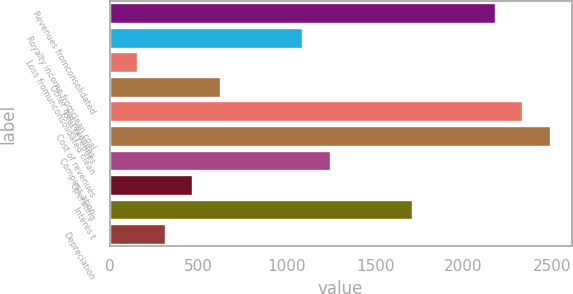Convert chart to OTSL. <chart><loc_0><loc_0><loc_500><loc_500><bar_chart><fcel>Revenues fromconsolidated<fcel>Royalty income fromclean coal<fcel>Loss fromunconsolidated clean<fcel>Other net revenues<fcel>Total revenues<fcel>Cost of revenues<fcel>Compens ation<fcel>Operating<fcel>Interes t<fcel>Depreciation<nl><fcel>2174.81<fcel>1087.5<fcel>155.52<fcel>621.51<fcel>2330.14<fcel>2485.47<fcel>1242.83<fcel>466.18<fcel>1708.82<fcel>310.85<nl></chart> 